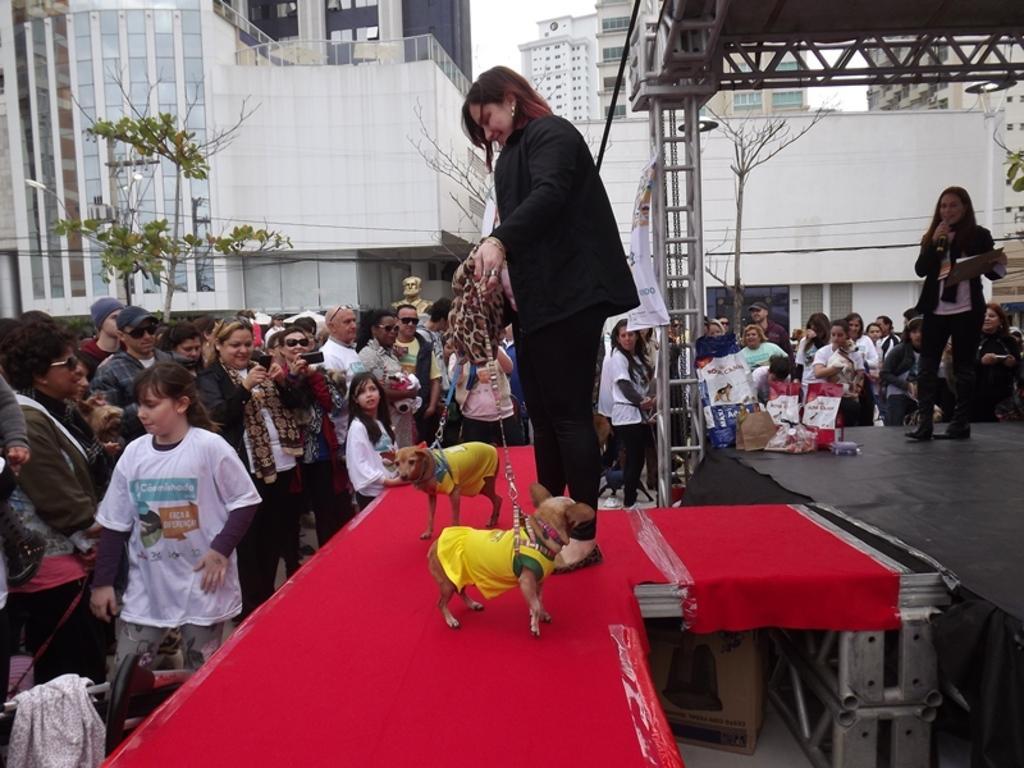In one or two sentences, can you explain what this image depicts? This picture shows a group of people standing and watching a woman standing and holding two dogs with strings with both her hands and we see a woman standing and speaking with the help of a microphone and we see buildings around and couple of trees 